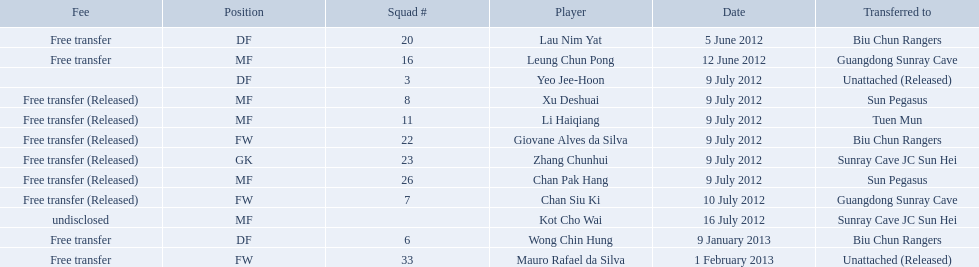On what dates were there non released free transfers? 5 June 2012, 12 June 2012, 9 January 2013, 1 February 2013. On which of these were the players transferred to another team? 5 June 2012, 12 June 2012, 9 January 2013. Which of these were the transfers to biu chun rangers? 5 June 2012, 9 January 2013. On which of those dated did they receive a df? 9 January 2013. 